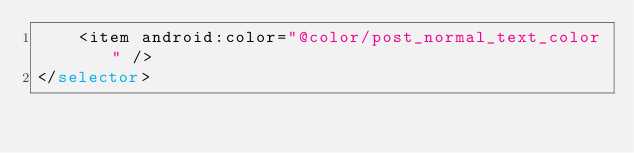<code> <loc_0><loc_0><loc_500><loc_500><_XML_>    <item android:color="@color/post_normal_text_color" />
</selector></code> 